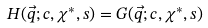Convert formula to latex. <formula><loc_0><loc_0><loc_500><loc_500>H ( \vec { q } ; c , \chi ^ { * } , s ) = G ( \vec { q } ; c , \chi ^ { * } , s )</formula> 